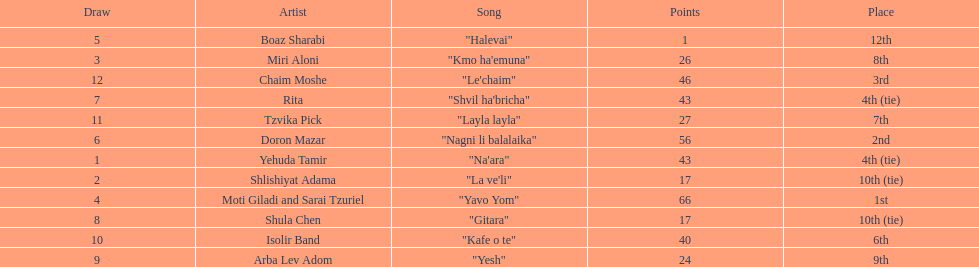What song earned the most points? "Yavo Yom". 